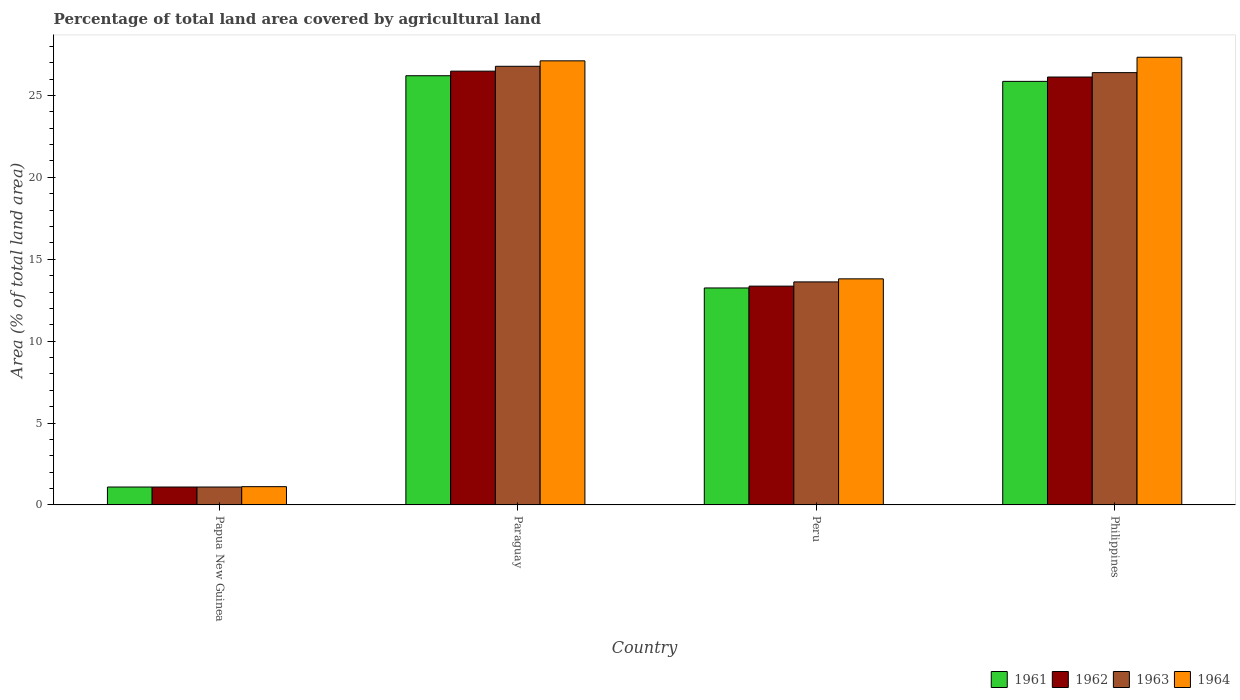How many different coloured bars are there?
Offer a very short reply. 4. Are the number of bars per tick equal to the number of legend labels?
Offer a very short reply. Yes. How many bars are there on the 4th tick from the right?
Give a very brief answer. 4. What is the label of the 1st group of bars from the left?
Provide a short and direct response. Papua New Guinea. What is the percentage of agricultural land in 1963 in Peru?
Ensure brevity in your answer.  13.62. Across all countries, what is the maximum percentage of agricultural land in 1961?
Offer a very short reply. 26.2. Across all countries, what is the minimum percentage of agricultural land in 1963?
Your response must be concise. 1.09. In which country was the percentage of agricultural land in 1963 maximum?
Keep it short and to the point. Paraguay. In which country was the percentage of agricultural land in 1964 minimum?
Keep it short and to the point. Papua New Guinea. What is the total percentage of agricultural land in 1961 in the graph?
Your response must be concise. 66.4. What is the difference between the percentage of agricultural land in 1961 in Papua New Guinea and that in Paraguay?
Your response must be concise. -25.11. What is the difference between the percentage of agricultural land in 1964 in Philippines and the percentage of agricultural land in 1961 in Paraguay?
Keep it short and to the point. 1.13. What is the average percentage of agricultural land in 1962 per country?
Make the answer very short. 16.77. What is the difference between the percentage of agricultural land of/in 1964 and percentage of agricultural land of/in 1961 in Peru?
Provide a succinct answer. 0.56. What is the ratio of the percentage of agricultural land in 1961 in Paraguay to that in Peru?
Keep it short and to the point. 1.98. Is the percentage of agricultural land in 1961 in Papua New Guinea less than that in Philippines?
Offer a very short reply. Yes. What is the difference between the highest and the second highest percentage of agricultural land in 1962?
Give a very brief answer. 0.36. What is the difference between the highest and the lowest percentage of agricultural land in 1963?
Offer a terse response. 25.69. In how many countries, is the percentage of agricultural land in 1961 greater than the average percentage of agricultural land in 1961 taken over all countries?
Your answer should be compact. 2. Is the sum of the percentage of agricultural land in 1962 in Paraguay and Philippines greater than the maximum percentage of agricultural land in 1963 across all countries?
Offer a very short reply. Yes. Is it the case that in every country, the sum of the percentage of agricultural land in 1964 and percentage of agricultural land in 1963 is greater than the sum of percentage of agricultural land in 1962 and percentage of agricultural land in 1961?
Give a very brief answer. No. What does the 2nd bar from the left in Peru represents?
Keep it short and to the point. 1962. What does the 2nd bar from the right in Peru represents?
Make the answer very short. 1963. How many bars are there?
Your answer should be compact. 16. Are all the bars in the graph horizontal?
Provide a succinct answer. No. How many countries are there in the graph?
Offer a very short reply. 4. What is the difference between two consecutive major ticks on the Y-axis?
Your answer should be very brief. 5. Are the values on the major ticks of Y-axis written in scientific E-notation?
Ensure brevity in your answer.  No. How many legend labels are there?
Provide a succinct answer. 4. How are the legend labels stacked?
Provide a short and direct response. Horizontal. What is the title of the graph?
Offer a terse response. Percentage of total land area covered by agricultural land. Does "2001" appear as one of the legend labels in the graph?
Make the answer very short. No. What is the label or title of the Y-axis?
Your response must be concise. Area (% of total land area). What is the Area (% of total land area) in 1961 in Papua New Guinea?
Give a very brief answer. 1.09. What is the Area (% of total land area) of 1962 in Papua New Guinea?
Give a very brief answer. 1.09. What is the Area (% of total land area) in 1963 in Papua New Guinea?
Your answer should be compact. 1.09. What is the Area (% of total land area) in 1964 in Papua New Guinea?
Give a very brief answer. 1.12. What is the Area (% of total land area) of 1961 in Paraguay?
Your response must be concise. 26.2. What is the Area (% of total land area) in 1962 in Paraguay?
Provide a succinct answer. 26.48. What is the Area (% of total land area) in 1963 in Paraguay?
Your answer should be very brief. 26.78. What is the Area (% of total land area) of 1964 in Paraguay?
Keep it short and to the point. 27.11. What is the Area (% of total land area) in 1961 in Peru?
Offer a terse response. 13.25. What is the Area (% of total land area) in 1962 in Peru?
Offer a very short reply. 13.36. What is the Area (% of total land area) of 1963 in Peru?
Provide a succinct answer. 13.62. What is the Area (% of total land area) in 1964 in Peru?
Ensure brevity in your answer.  13.8. What is the Area (% of total land area) of 1961 in Philippines?
Ensure brevity in your answer.  25.86. What is the Area (% of total land area) of 1962 in Philippines?
Your answer should be compact. 26.12. What is the Area (% of total land area) in 1963 in Philippines?
Your answer should be compact. 26.39. What is the Area (% of total land area) of 1964 in Philippines?
Provide a short and direct response. 27.33. Across all countries, what is the maximum Area (% of total land area) of 1961?
Give a very brief answer. 26.2. Across all countries, what is the maximum Area (% of total land area) of 1962?
Provide a short and direct response. 26.48. Across all countries, what is the maximum Area (% of total land area) in 1963?
Your answer should be very brief. 26.78. Across all countries, what is the maximum Area (% of total land area) in 1964?
Offer a terse response. 27.33. Across all countries, what is the minimum Area (% of total land area) of 1961?
Give a very brief answer. 1.09. Across all countries, what is the minimum Area (% of total land area) of 1962?
Ensure brevity in your answer.  1.09. Across all countries, what is the minimum Area (% of total land area) of 1963?
Give a very brief answer. 1.09. Across all countries, what is the minimum Area (% of total land area) in 1964?
Provide a succinct answer. 1.12. What is the total Area (% of total land area) of 1961 in the graph?
Offer a very short reply. 66.4. What is the total Area (% of total land area) of 1962 in the graph?
Provide a short and direct response. 67.06. What is the total Area (% of total land area) in 1963 in the graph?
Ensure brevity in your answer.  67.88. What is the total Area (% of total land area) of 1964 in the graph?
Provide a short and direct response. 69.36. What is the difference between the Area (% of total land area) of 1961 in Papua New Guinea and that in Paraguay?
Provide a short and direct response. -25.11. What is the difference between the Area (% of total land area) of 1962 in Papua New Guinea and that in Paraguay?
Give a very brief answer. -25.39. What is the difference between the Area (% of total land area) of 1963 in Papua New Guinea and that in Paraguay?
Give a very brief answer. -25.69. What is the difference between the Area (% of total land area) of 1964 in Papua New Guinea and that in Paraguay?
Provide a succinct answer. -26. What is the difference between the Area (% of total land area) in 1961 in Papua New Guinea and that in Peru?
Provide a succinct answer. -12.15. What is the difference between the Area (% of total land area) in 1962 in Papua New Guinea and that in Peru?
Your answer should be compact. -12.27. What is the difference between the Area (% of total land area) of 1963 in Papua New Guinea and that in Peru?
Make the answer very short. -12.52. What is the difference between the Area (% of total land area) in 1964 in Papua New Guinea and that in Peru?
Your response must be concise. -12.69. What is the difference between the Area (% of total land area) of 1961 in Papua New Guinea and that in Philippines?
Ensure brevity in your answer.  -24.77. What is the difference between the Area (% of total land area) in 1962 in Papua New Guinea and that in Philippines?
Your answer should be very brief. -25.03. What is the difference between the Area (% of total land area) in 1963 in Papua New Guinea and that in Philippines?
Offer a terse response. -25.3. What is the difference between the Area (% of total land area) in 1964 in Papua New Guinea and that in Philippines?
Give a very brief answer. -26.22. What is the difference between the Area (% of total land area) of 1961 in Paraguay and that in Peru?
Ensure brevity in your answer.  12.96. What is the difference between the Area (% of total land area) in 1962 in Paraguay and that in Peru?
Your answer should be compact. 13.13. What is the difference between the Area (% of total land area) of 1963 in Paraguay and that in Peru?
Offer a very short reply. 13.16. What is the difference between the Area (% of total land area) in 1964 in Paraguay and that in Peru?
Keep it short and to the point. 13.31. What is the difference between the Area (% of total land area) of 1961 in Paraguay and that in Philippines?
Make the answer very short. 0.34. What is the difference between the Area (% of total land area) in 1962 in Paraguay and that in Philippines?
Offer a terse response. 0.36. What is the difference between the Area (% of total land area) in 1963 in Paraguay and that in Philippines?
Give a very brief answer. 0.39. What is the difference between the Area (% of total land area) of 1964 in Paraguay and that in Philippines?
Your response must be concise. -0.22. What is the difference between the Area (% of total land area) in 1961 in Peru and that in Philippines?
Your response must be concise. -12.61. What is the difference between the Area (% of total land area) of 1962 in Peru and that in Philippines?
Provide a short and direct response. -12.77. What is the difference between the Area (% of total land area) in 1963 in Peru and that in Philippines?
Ensure brevity in your answer.  -12.78. What is the difference between the Area (% of total land area) in 1964 in Peru and that in Philippines?
Offer a very short reply. -13.53. What is the difference between the Area (% of total land area) in 1961 in Papua New Guinea and the Area (% of total land area) in 1962 in Paraguay?
Your response must be concise. -25.39. What is the difference between the Area (% of total land area) in 1961 in Papua New Guinea and the Area (% of total land area) in 1963 in Paraguay?
Provide a short and direct response. -25.69. What is the difference between the Area (% of total land area) in 1961 in Papua New Guinea and the Area (% of total land area) in 1964 in Paraguay?
Your response must be concise. -26.02. What is the difference between the Area (% of total land area) of 1962 in Papua New Guinea and the Area (% of total land area) of 1963 in Paraguay?
Provide a succinct answer. -25.69. What is the difference between the Area (% of total land area) in 1962 in Papua New Guinea and the Area (% of total land area) in 1964 in Paraguay?
Ensure brevity in your answer.  -26.02. What is the difference between the Area (% of total land area) of 1963 in Papua New Guinea and the Area (% of total land area) of 1964 in Paraguay?
Keep it short and to the point. -26.02. What is the difference between the Area (% of total land area) of 1961 in Papua New Guinea and the Area (% of total land area) of 1962 in Peru?
Your answer should be compact. -12.27. What is the difference between the Area (% of total land area) of 1961 in Papua New Guinea and the Area (% of total land area) of 1963 in Peru?
Keep it short and to the point. -12.52. What is the difference between the Area (% of total land area) of 1961 in Papua New Guinea and the Area (% of total land area) of 1964 in Peru?
Make the answer very short. -12.71. What is the difference between the Area (% of total land area) of 1962 in Papua New Guinea and the Area (% of total land area) of 1963 in Peru?
Keep it short and to the point. -12.52. What is the difference between the Area (% of total land area) of 1962 in Papua New Guinea and the Area (% of total land area) of 1964 in Peru?
Ensure brevity in your answer.  -12.71. What is the difference between the Area (% of total land area) of 1963 in Papua New Guinea and the Area (% of total land area) of 1964 in Peru?
Ensure brevity in your answer.  -12.71. What is the difference between the Area (% of total land area) in 1961 in Papua New Guinea and the Area (% of total land area) in 1962 in Philippines?
Your answer should be very brief. -25.03. What is the difference between the Area (% of total land area) of 1961 in Papua New Guinea and the Area (% of total land area) of 1963 in Philippines?
Make the answer very short. -25.3. What is the difference between the Area (% of total land area) of 1961 in Papua New Guinea and the Area (% of total land area) of 1964 in Philippines?
Ensure brevity in your answer.  -26.24. What is the difference between the Area (% of total land area) of 1962 in Papua New Guinea and the Area (% of total land area) of 1963 in Philippines?
Your answer should be very brief. -25.3. What is the difference between the Area (% of total land area) of 1962 in Papua New Guinea and the Area (% of total land area) of 1964 in Philippines?
Offer a very short reply. -26.24. What is the difference between the Area (% of total land area) in 1963 in Papua New Guinea and the Area (% of total land area) in 1964 in Philippines?
Your answer should be compact. -26.24. What is the difference between the Area (% of total land area) of 1961 in Paraguay and the Area (% of total land area) of 1962 in Peru?
Keep it short and to the point. 12.85. What is the difference between the Area (% of total land area) in 1961 in Paraguay and the Area (% of total land area) in 1963 in Peru?
Offer a terse response. 12.59. What is the difference between the Area (% of total land area) in 1961 in Paraguay and the Area (% of total land area) in 1964 in Peru?
Make the answer very short. 12.4. What is the difference between the Area (% of total land area) in 1962 in Paraguay and the Area (% of total land area) in 1963 in Peru?
Your answer should be very brief. 12.87. What is the difference between the Area (% of total land area) in 1962 in Paraguay and the Area (% of total land area) in 1964 in Peru?
Offer a terse response. 12.68. What is the difference between the Area (% of total land area) of 1963 in Paraguay and the Area (% of total land area) of 1964 in Peru?
Provide a succinct answer. 12.98. What is the difference between the Area (% of total land area) in 1961 in Paraguay and the Area (% of total land area) in 1962 in Philippines?
Your response must be concise. 0.08. What is the difference between the Area (% of total land area) of 1961 in Paraguay and the Area (% of total land area) of 1963 in Philippines?
Provide a succinct answer. -0.19. What is the difference between the Area (% of total land area) in 1961 in Paraguay and the Area (% of total land area) in 1964 in Philippines?
Make the answer very short. -1.13. What is the difference between the Area (% of total land area) in 1962 in Paraguay and the Area (% of total land area) in 1963 in Philippines?
Your answer should be very brief. 0.09. What is the difference between the Area (% of total land area) of 1962 in Paraguay and the Area (% of total land area) of 1964 in Philippines?
Keep it short and to the point. -0.85. What is the difference between the Area (% of total land area) in 1963 in Paraguay and the Area (% of total land area) in 1964 in Philippines?
Your response must be concise. -0.55. What is the difference between the Area (% of total land area) in 1961 in Peru and the Area (% of total land area) in 1962 in Philippines?
Offer a very short reply. -12.88. What is the difference between the Area (% of total land area) in 1961 in Peru and the Area (% of total land area) in 1963 in Philippines?
Keep it short and to the point. -13.15. What is the difference between the Area (% of total land area) in 1961 in Peru and the Area (% of total land area) in 1964 in Philippines?
Give a very brief answer. -14.09. What is the difference between the Area (% of total land area) of 1962 in Peru and the Area (% of total land area) of 1963 in Philippines?
Ensure brevity in your answer.  -13.03. What is the difference between the Area (% of total land area) in 1962 in Peru and the Area (% of total land area) in 1964 in Philippines?
Provide a succinct answer. -13.97. What is the difference between the Area (% of total land area) of 1963 in Peru and the Area (% of total land area) of 1964 in Philippines?
Provide a succinct answer. -13.71. What is the average Area (% of total land area) in 1961 per country?
Your answer should be compact. 16.6. What is the average Area (% of total land area) in 1962 per country?
Your response must be concise. 16.77. What is the average Area (% of total land area) of 1963 per country?
Provide a short and direct response. 16.97. What is the average Area (% of total land area) of 1964 per country?
Give a very brief answer. 17.34. What is the difference between the Area (% of total land area) of 1961 and Area (% of total land area) of 1963 in Papua New Guinea?
Provide a short and direct response. 0. What is the difference between the Area (% of total land area) in 1961 and Area (% of total land area) in 1964 in Papua New Guinea?
Your response must be concise. -0.02. What is the difference between the Area (% of total land area) in 1962 and Area (% of total land area) in 1963 in Papua New Guinea?
Provide a short and direct response. 0. What is the difference between the Area (% of total land area) in 1962 and Area (% of total land area) in 1964 in Papua New Guinea?
Give a very brief answer. -0.02. What is the difference between the Area (% of total land area) in 1963 and Area (% of total land area) in 1964 in Papua New Guinea?
Provide a short and direct response. -0.02. What is the difference between the Area (% of total land area) in 1961 and Area (% of total land area) in 1962 in Paraguay?
Offer a very short reply. -0.28. What is the difference between the Area (% of total land area) of 1961 and Area (% of total land area) of 1963 in Paraguay?
Make the answer very short. -0.58. What is the difference between the Area (% of total land area) in 1961 and Area (% of total land area) in 1964 in Paraguay?
Your answer should be very brief. -0.91. What is the difference between the Area (% of total land area) of 1962 and Area (% of total land area) of 1963 in Paraguay?
Ensure brevity in your answer.  -0.3. What is the difference between the Area (% of total land area) of 1962 and Area (% of total land area) of 1964 in Paraguay?
Your answer should be very brief. -0.63. What is the difference between the Area (% of total land area) of 1963 and Area (% of total land area) of 1964 in Paraguay?
Make the answer very short. -0.33. What is the difference between the Area (% of total land area) of 1961 and Area (% of total land area) of 1962 in Peru?
Your response must be concise. -0.11. What is the difference between the Area (% of total land area) of 1961 and Area (% of total land area) of 1963 in Peru?
Your answer should be very brief. -0.37. What is the difference between the Area (% of total land area) of 1961 and Area (% of total land area) of 1964 in Peru?
Offer a very short reply. -0.56. What is the difference between the Area (% of total land area) of 1962 and Area (% of total land area) of 1963 in Peru?
Offer a very short reply. -0.26. What is the difference between the Area (% of total land area) of 1962 and Area (% of total land area) of 1964 in Peru?
Provide a succinct answer. -0.44. What is the difference between the Area (% of total land area) of 1963 and Area (% of total land area) of 1964 in Peru?
Your answer should be very brief. -0.19. What is the difference between the Area (% of total land area) in 1961 and Area (% of total land area) in 1962 in Philippines?
Provide a succinct answer. -0.26. What is the difference between the Area (% of total land area) in 1961 and Area (% of total land area) in 1963 in Philippines?
Your answer should be very brief. -0.53. What is the difference between the Area (% of total land area) of 1961 and Area (% of total land area) of 1964 in Philippines?
Offer a terse response. -1.47. What is the difference between the Area (% of total land area) in 1962 and Area (% of total land area) in 1963 in Philippines?
Ensure brevity in your answer.  -0.27. What is the difference between the Area (% of total land area) of 1962 and Area (% of total land area) of 1964 in Philippines?
Your response must be concise. -1.21. What is the difference between the Area (% of total land area) in 1963 and Area (% of total land area) in 1964 in Philippines?
Your answer should be very brief. -0.94. What is the ratio of the Area (% of total land area) of 1961 in Papua New Guinea to that in Paraguay?
Your answer should be compact. 0.04. What is the ratio of the Area (% of total land area) in 1962 in Papua New Guinea to that in Paraguay?
Keep it short and to the point. 0.04. What is the ratio of the Area (% of total land area) in 1963 in Papua New Guinea to that in Paraguay?
Provide a succinct answer. 0.04. What is the ratio of the Area (% of total land area) of 1964 in Papua New Guinea to that in Paraguay?
Provide a short and direct response. 0.04. What is the ratio of the Area (% of total land area) in 1961 in Papua New Guinea to that in Peru?
Provide a succinct answer. 0.08. What is the ratio of the Area (% of total land area) of 1962 in Papua New Guinea to that in Peru?
Your answer should be compact. 0.08. What is the ratio of the Area (% of total land area) of 1963 in Papua New Guinea to that in Peru?
Ensure brevity in your answer.  0.08. What is the ratio of the Area (% of total land area) of 1964 in Papua New Guinea to that in Peru?
Ensure brevity in your answer.  0.08. What is the ratio of the Area (% of total land area) in 1961 in Papua New Guinea to that in Philippines?
Provide a short and direct response. 0.04. What is the ratio of the Area (% of total land area) in 1962 in Papua New Guinea to that in Philippines?
Your answer should be very brief. 0.04. What is the ratio of the Area (% of total land area) in 1963 in Papua New Guinea to that in Philippines?
Give a very brief answer. 0.04. What is the ratio of the Area (% of total land area) in 1964 in Papua New Guinea to that in Philippines?
Your answer should be very brief. 0.04. What is the ratio of the Area (% of total land area) in 1961 in Paraguay to that in Peru?
Provide a succinct answer. 1.98. What is the ratio of the Area (% of total land area) in 1962 in Paraguay to that in Peru?
Provide a succinct answer. 1.98. What is the ratio of the Area (% of total land area) of 1963 in Paraguay to that in Peru?
Your response must be concise. 1.97. What is the ratio of the Area (% of total land area) of 1964 in Paraguay to that in Peru?
Ensure brevity in your answer.  1.96. What is the ratio of the Area (% of total land area) of 1961 in Paraguay to that in Philippines?
Give a very brief answer. 1.01. What is the ratio of the Area (% of total land area) of 1962 in Paraguay to that in Philippines?
Your answer should be compact. 1.01. What is the ratio of the Area (% of total land area) in 1963 in Paraguay to that in Philippines?
Your response must be concise. 1.01. What is the ratio of the Area (% of total land area) in 1964 in Paraguay to that in Philippines?
Your answer should be compact. 0.99. What is the ratio of the Area (% of total land area) in 1961 in Peru to that in Philippines?
Your answer should be very brief. 0.51. What is the ratio of the Area (% of total land area) in 1962 in Peru to that in Philippines?
Provide a succinct answer. 0.51. What is the ratio of the Area (% of total land area) of 1963 in Peru to that in Philippines?
Offer a terse response. 0.52. What is the ratio of the Area (% of total land area) in 1964 in Peru to that in Philippines?
Offer a very short reply. 0.51. What is the difference between the highest and the second highest Area (% of total land area) in 1961?
Provide a short and direct response. 0.34. What is the difference between the highest and the second highest Area (% of total land area) in 1962?
Your answer should be very brief. 0.36. What is the difference between the highest and the second highest Area (% of total land area) in 1963?
Give a very brief answer. 0.39. What is the difference between the highest and the second highest Area (% of total land area) in 1964?
Give a very brief answer. 0.22. What is the difference between the highest and the lowest Area (% of total land area) in 1961?
Offer a terse response. 25.11. What is the difference between the highest and the lowest Area (% of total land area) in 1962?
Offer a very short reply. 25.39. What is the difference between the highest and the lowest Area (% of total land area) of 1963?
Your answer should be very brief. 25.69. What is the difference between the highest and the lowest Area (% of total land area) of 1964?
Keep it short and to the point. 26.22. 